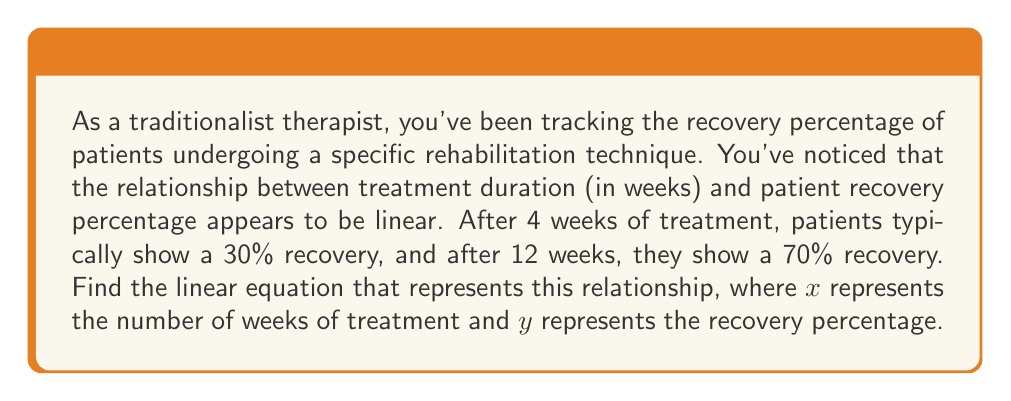Give your solution to this math problem. To find the linear equation, we'll use the point-slope form of a line: $y - y_1 = m(x - x_1)$, where $m$ is the slope.

1. First, let's calculate the slope using the two given points:
   $(x_1, y_1) = (4, 30)$ and $(x_2, y_2) = (12, 70)$

   $m = \frac{y_2 - y_1}{x_2 - x_1} = \frac{70 - 30}{12 - 4} = \frac{40}{8} = 5$

2. Now we have the slope, let's use the point $(4, 30)$ in the point-slope form:

   $y - 30 = 5(x - 4)$

3. Expand the equation:

   $y - 30 = 5x - 20$

4. Add 30 to both sides to get the equation in slope-intercept form $(y = mx + b)$:

   $y = 5x - 20 + 30$
   $y = 5x + 10$

5. Therefore, the linear equation representing the relationship between treatment duration and recovery percentage is:

   $y = 5x + 10$

   Where $x$ is the number of weeks of treatment and $y$ is the recovery percentage.
Answer: $y = 5x + 10$, where $x$ is the number of weeks of treatment and $y$ is the recovery percentage. 